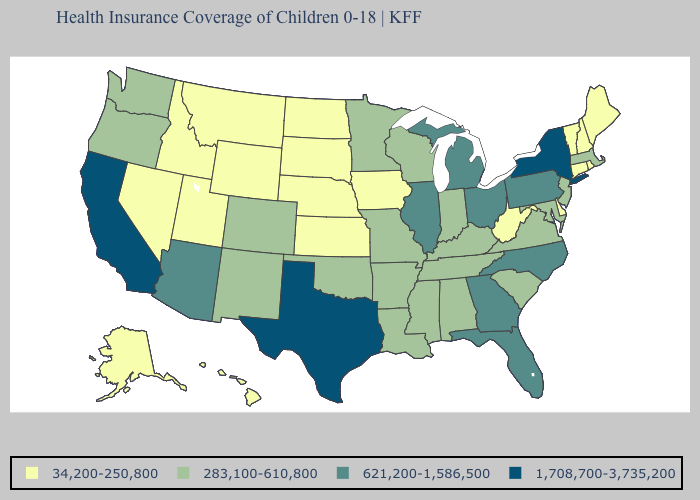Name the states that have a value in the range 621,200-1,586,500?
Keep it brief. Arizona, Florida, Georgia, Illinois, Michigan, North Carolina, Ohio, Pennsylvania. Among the states that border New Hampshire , does Maine have the lowest value?
Be succinct. Yes. What is the lowest value in the USA?
Keep it brief. 34,200-250,800. Among the states that border Delaware , which have the highest value?
Give a very brief answer. Pennsylvania. Name the states that have a value in the range 283,100-610,800?
Keep it brief. Alabama, Arkansas, Colorado, Indiana, Kentucky, Louisiana, Maryland, Massachusetts, Minnesota, Mississippi, Missouri, New Jersey, New Mexico, Oklahoma, Oregon, South Carolina, Tennessee, Virginia, Washington, Wisconsin. Does Illinois have the highest value in the MidWest?
Keep it brief. Yes. Does Delaware have the lowest value in the USA?
Keep it brief. Yes. Which states have the highest value in the USA?
Be succinct. California, New York, Texas. Does New Jersey have the lowest value in the Northeast?
Give a very brief answer. No. Does Virginia have a lower value than Georgia?
Keep it brief. Yes. Does Washington have the lowest value in the West?
Short answer required. No. What is the highest value in the South ?
Give a very brief answer. 1,708,700-3,735,200. Which states have the lowest value in the MidWest?
Be succinct. Iowa, Kansas, Nebraska, North Dakota, South Dakota. What is the highest value in states that border New Jersey?
Be succinct. 1,708,700-3,735,200. What is the lowest value in the Northeast?
Quick response, please. 34,200-250,800. 